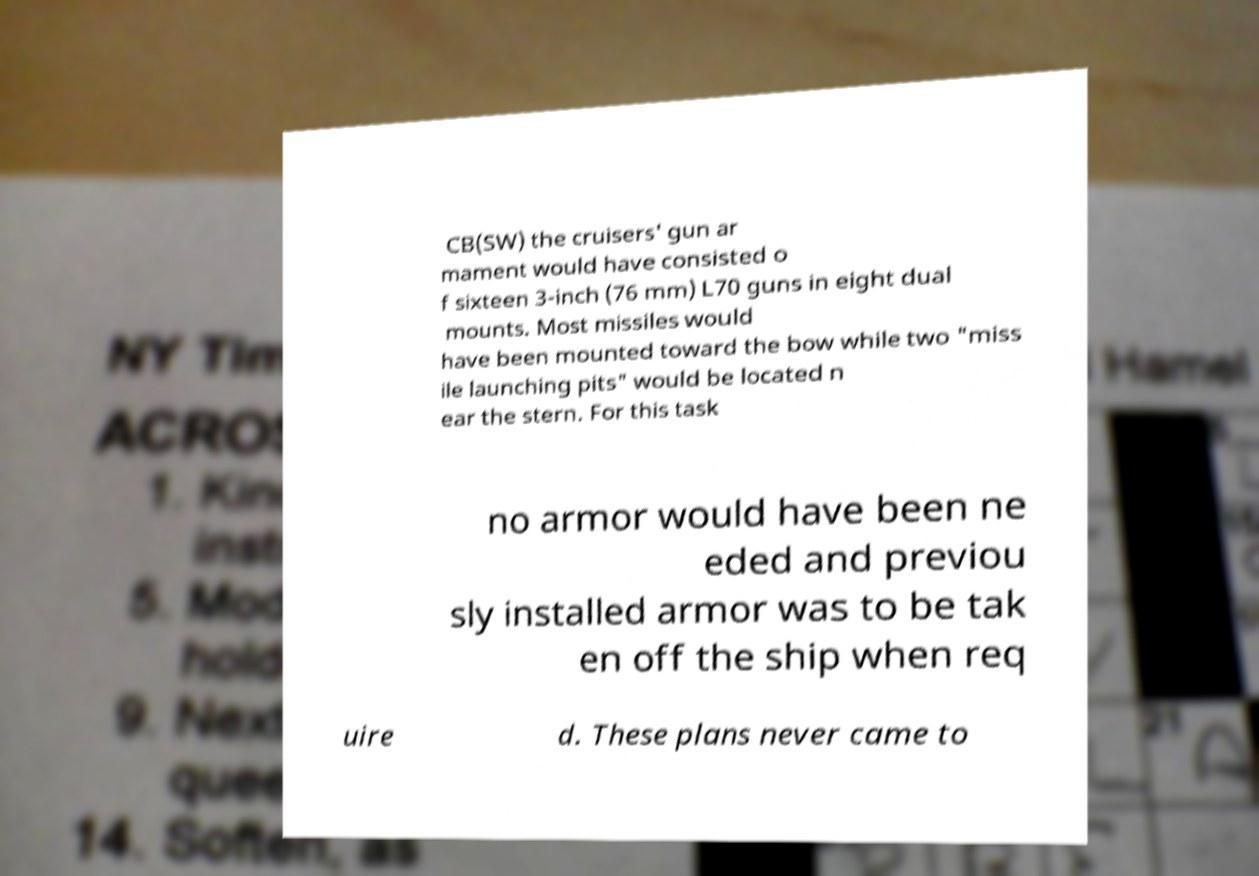I need the written content from this picture converted into text. Can you do that? CB(SW) the cruisers' gun ar mament would have consisted o f sixteen 3-inch (76 mm) L70 guns in eight dual mounts. Most missiles would have been mounted toward the bow while two "miss ile launching pits" would be located n ear the stern. For this task no armor would have been ne eded and previou sly installed armor was to be tak en off the ship when req uire d. These plans never came to 